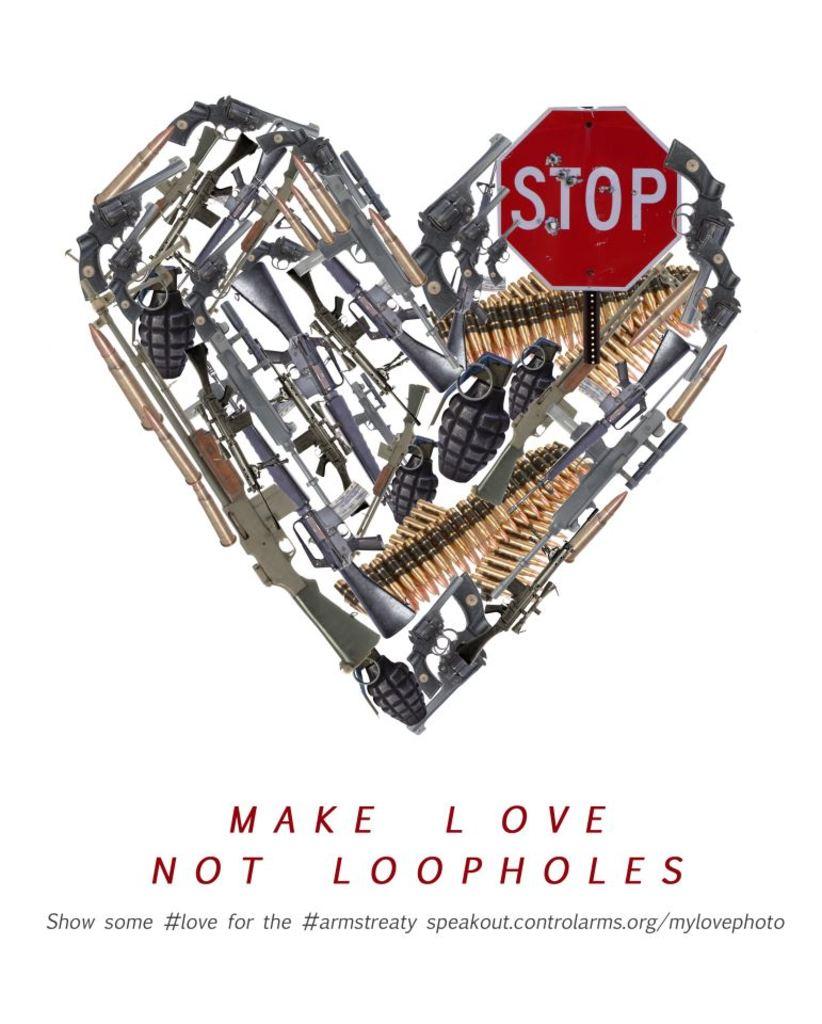What does it tell you to make?
Offer a terse response. Love. What kind of sign is shown?
Give a very brief answer. Stop. 